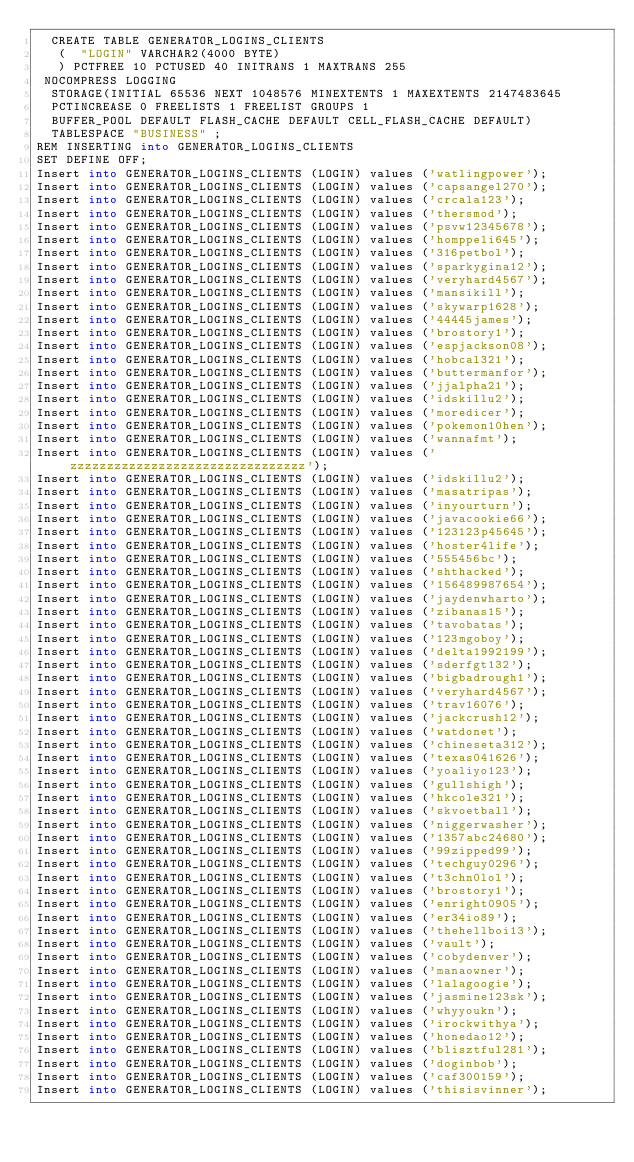Convert code to text. <code><loc_0><loc_0><loc_500><loc_500><_SQL_>  CREATE TABLE GENERATOR_LOGINS_CLIENTS 
   (	"LOGIN" VARCHAR2(4000 BYTE)
   ) PCTFREE 10 PCTUSED 40 INITRANS 1 MAXTRANS 255 
 NOCOMPRESS LOGGING
  STORAGE(INITIAL 65536 NEXT 1048576 MINEXTENTS 1 MAXEXTENTS 2147483645
  PCTINCREASE 0 FREELISTS 1 FREELIST GROUPS 1
  BUFFER_POOL DEFAULT FLASH_CACHE DEFAULT CELL_FLASH_CACHE DEFAULT)
  TABLESPACE "BUSINESS" ;
REM INSERTING into GENERATOR_LOGINS_CLIENTS
SET DEFINE OFF;
Insert into GENERATOR_LOGINS_CLIENTS (LOGIN) values ('watlingpower');
Insert into GENERATOR_LOGINS_CLIENTS (LOGIN) values ('capsangel270');
Insert into GENERATOR_LOGINS_CLIENTS (LOGIN) values ('crcala123');
Insert into GENERATOR_LOGINS_CLIENTS (LOGIN) values ('thersmod');
Insert into GENERATOR_LOGINS_CLIENTS (LOGIN) values ('psvw12345678');
Insert into GENERATOR_LOGINS_CLIENTS (LOGIN) values ('homppeli645');
Insert into GENERATOR_LOGINS_CLIENTS (LOGIN) values ('316petbol');
Insert into GENERATOR_LOGINS_CLIENTS (LOGIN) values ('sparkygina12');
Insert into GENERATOR_LOGINS_CLIENTS (LOGIN) values ('veryhard4567');
Insert into GENERATOR_LOGINS_CLIENTS (LOGIN) values ('mansikill');
Insert into GENERATOR_LOGINS_CLIENTS (LOGIN) values ('skywarp1628');
Insert into GENERATOR_LOGINS_CLIENTS (LOGIN) values ('44445james');
Insert into GENERATOR_LOGINS_CLIENTS (LOGIN) values ('brostory1');
Insert into GENERATOR_LOGINS_CLIENTS (LOGIN) values ('espjackson08');
Insert into GENERATOR_LOGINS_CLIENTS (LOGIN) values ('hobcal321');
Insert into GENERATOR_LOGINS_CLIENTS (LOGIN) values ('buttermanfor');
Insert into GENERATOR_LOGINS_CLIENTS (LOGIN) values ('jjalpha21');
Insert into GENERATOR_LOGINS_CLIENTS (LOGIN) values ('idskillu2');
Insert into GENERATOR_LOGINS_CLIENTS (LOGIN) values ('moredicer');
Insert into GENERATOR_LOGINS_CLIENTS (LOGIN) values ('pokemon10hen');
Insert into GENERATOR_LOGINS_CLIENTS (LOGIN) values ('wannafmt');
Insert into GENERATOR_LOGINS_CLIENTS (LOGIN) values ('zzzzzzzzzzzzzzzzzzzzzzzzzzzzzzzz');
Insert into GENERATOR_LOGINS_CLIENTS (LOGIN) values ('idskillu2');
Insert into GENERATOR_LOGINS_CLIENTS (LOGIN) values ('masatripas');
Insert into GENERATOR_LOGINS_CLIENTS (LOGIN) values ('inyourturn');
Insert into GENERATOR_LOGINS_CLIENTS (LOGIN) values ('javacookie66');
Insert into GENERATOR_LOGINS_CLIENTS (LOGIN) values ('123123p45645');
Insert into GENERATOR_LOGINS_CLIENTS (LOGIN) values ('hoster4life');
Insert into GENERATOR_LOGINS_CLIENTS (LOGIN) values ('555456bc');
Insert into GENERATOR_LOGINS_CLIENTS (LOGIN) values ('shthacked');
Insert into GENERATOR_LOGINS_CLIENTS (LOGIN) values ('156489987654');
Insert into GENERATOR_LOGINS_CLIENTS (LOGIN) values ('jaydenwharto');
Insert into GENERATOR_LOGINS_CLIENTS (LOGIN) values ('zibanas15');
Insert into GENERATOR_LOGINS_CLIENTS (LOGIN) values ('tavobatas');
Insert into GENERATOR_LOGINS_CLIENTS (LOGIN) values ('123mgoboy');
Insert into GENERATOR_LOGINS_CLIENTS (LOGIN) values ('delta1992199');
Insert into GENERATOR_LOGINS_CLIENTS (LOGIN) values ('sderfgt132');
Insert into GENERATOR_LOGINS_CLIENTS (LOGIN) values ('bigbadrough1');
Insert into GENERATOR_LOGINS_CLIENTS (LOGIN) values ('veryhard4567');
Insert into GENERATOR_LOGINS_CLIENTS (LOGIN) values ('trav16076');
Insert into GENERATOR_LOGINS_CLIENTS (LOGIN) values ('jackcrush12');
Insert into GENERATOR_LOGINS_CLIENTS (LOGIN) values ('watdonet');
Insert into GENERATOR_LOGINS_CLIENTS (LOGIN) values ('chineseta312');
Insert into GENERATOR_LOGINS_CLIENTS (LOGIN) values ('texas041626');
Insert into GENERATOR_LOGINS_CLIENTS (LOGIN) values ('yoaliyo123');
Insert into GENERATOR_LOGINS_CLIENTS (LOGIN) values ('gullshigh');
Insert into GENERATOR_LOGINS_CLIENTS (LOGIN) values ('hkcole321');
Insert into GENERATOR_LOGINS_CLIENTS (LOGIN) values ('skvoetball');
Insert into GENERATOR_LOGINS_CLIENTS (LOGIN) values ('niggerwasher');
Insert into GENERATOR_LOGINS_CLIENTS (LOGIN) values ('1357abc24680');
Insert into GENERATOR_LOGINS_CLIENTS (LOGIN) values ('99zipped99');
Insert into GENERATOR_LOGINS_CLIENTS (LOGIN) values ('techguy0296');
Insert into GENERATOR_LOGINS_CLIENTS (LOGIN) values ('t3chn0lol');
Insert into GENERATOR_LOGINS_CLIENTS (LOGIN) values ('brostory1');
Insert into GENERATOR_LOGINS_CLIENTS (LOGIN) values ('enright0905');
Insert into GENERATOR_LOGINS_CLIENTS (LOGIN) values ('er34io89');
Insert into GENERATOR_LOGINS_CLIENTS (LOGIN) values ('thehellboi13');
Insert into GENERATOR_LOGINS_CLIENTS (LOGIN) values ('vault');
Insert into GENERATOR_LOGINS_CLIENTS (LOGIN) values ('cobydenver');
Insert into GENERATOR_LOGINS_CLIENTS (LOGIN) values ('manaowner');
Insert into GENERATOR_LOGINS_CLIENTS (LOGIN) values ('lalagoogie');
Insert into GENERATOR_LOGINS_CLIENTS (LOGIN) values ('jasmine123sk');
Insert into GENERATOR_LOGINS_CLIENTS (LOGIN) values ('whyyoukn');
Insert into GENERATOR_LOGINS_CLIENTS (LOGIN) values ('irockwithya');
Insert into GENERATOR_LOGINS_CLIENTS (LOGIN) values ('honedao12');
Insert into GENERATOR_LOGINS_CLIENTS (LOGIN) values ('blisztful281');
Insert into GENERATOR_LOGINS_CLIENTS (LOGIN) values ('doginbob');
Insert into GENERATOR_LOGINS_CLIENTS (LOGIN) values ('caf300159');
Insert into GENERATOR_LOGINS_CLIENTS (LOGIN) values ('thisisvinner');</code> 